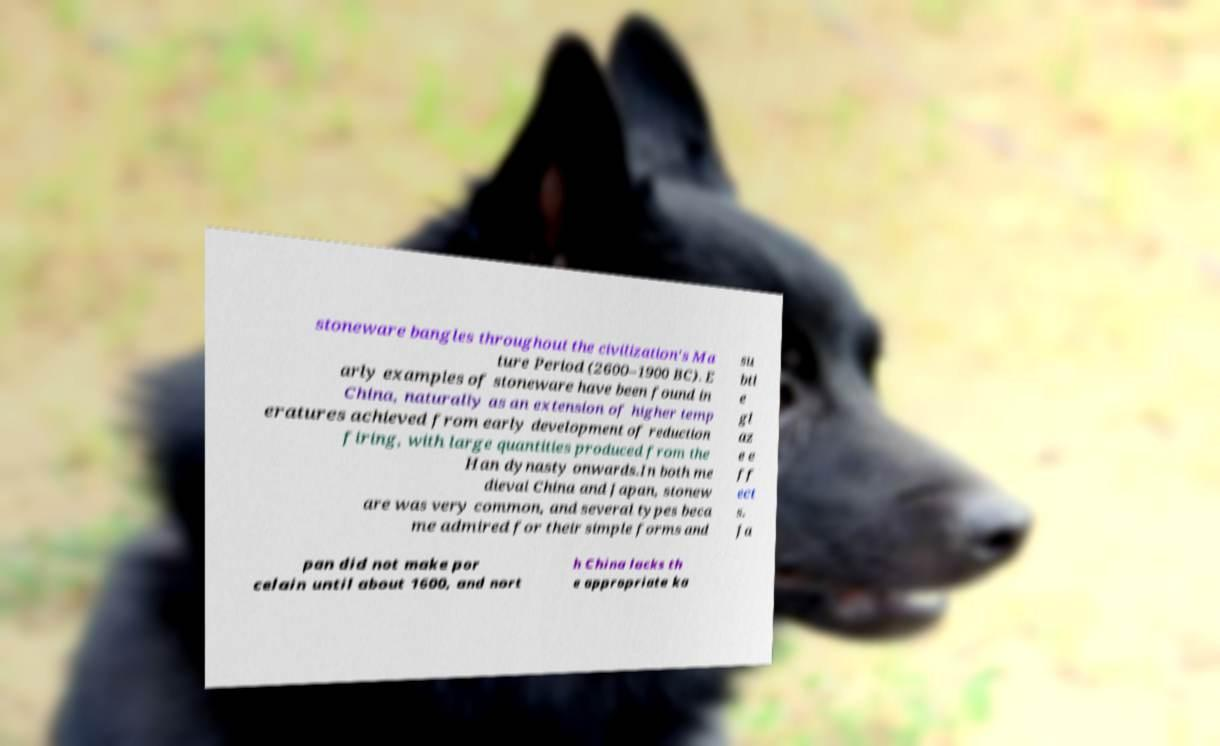What messages or text are displayed in this image? I need them in a readable, typed format. stoneware bangles throughout the civilization's Ma ture Period (2600–1900 BC). E arly examples of stoneware have been found in China, naturally as an extension of higher temp eratures achieved from early development of reduction firing, with large quantities produced from the Han dynasty onwards.In both me dieval China and Japan, stonew are was very common, and several types beca me admired for their simple forms and su btl e gl az e e ff ect s. Ja pan did not make por celain until about 1600, and nort h China lacks th e appropriate ka 